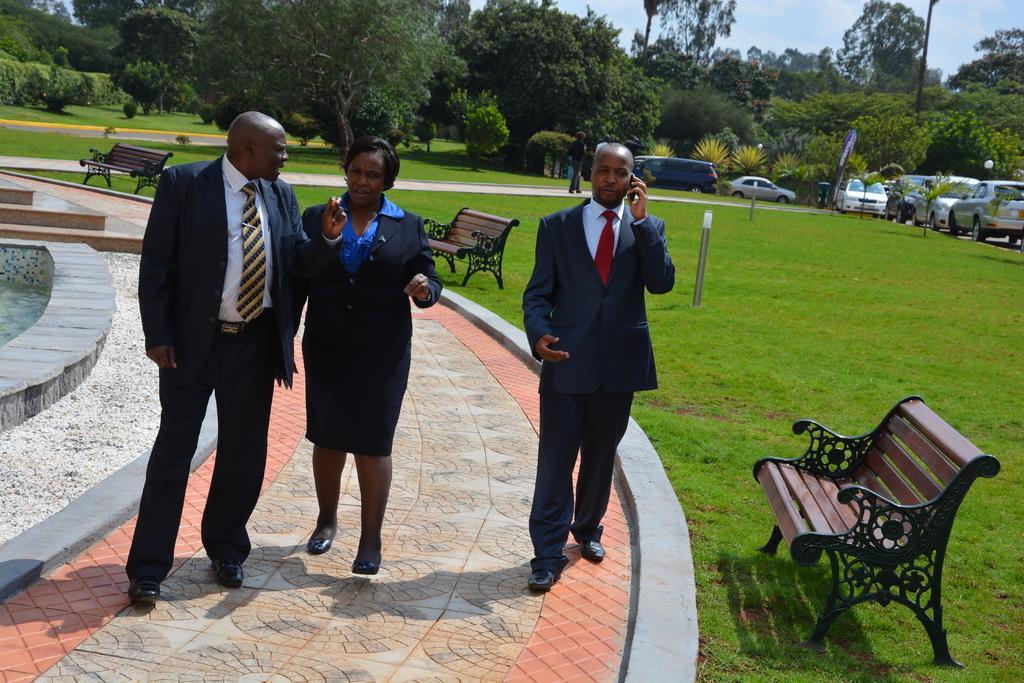Describe this image in one or two sentences. In the image we can see there are people who are standing on the footpath and there is a ground which is covered with grass and cars are parked on the road and at the back there are lot of trees. 